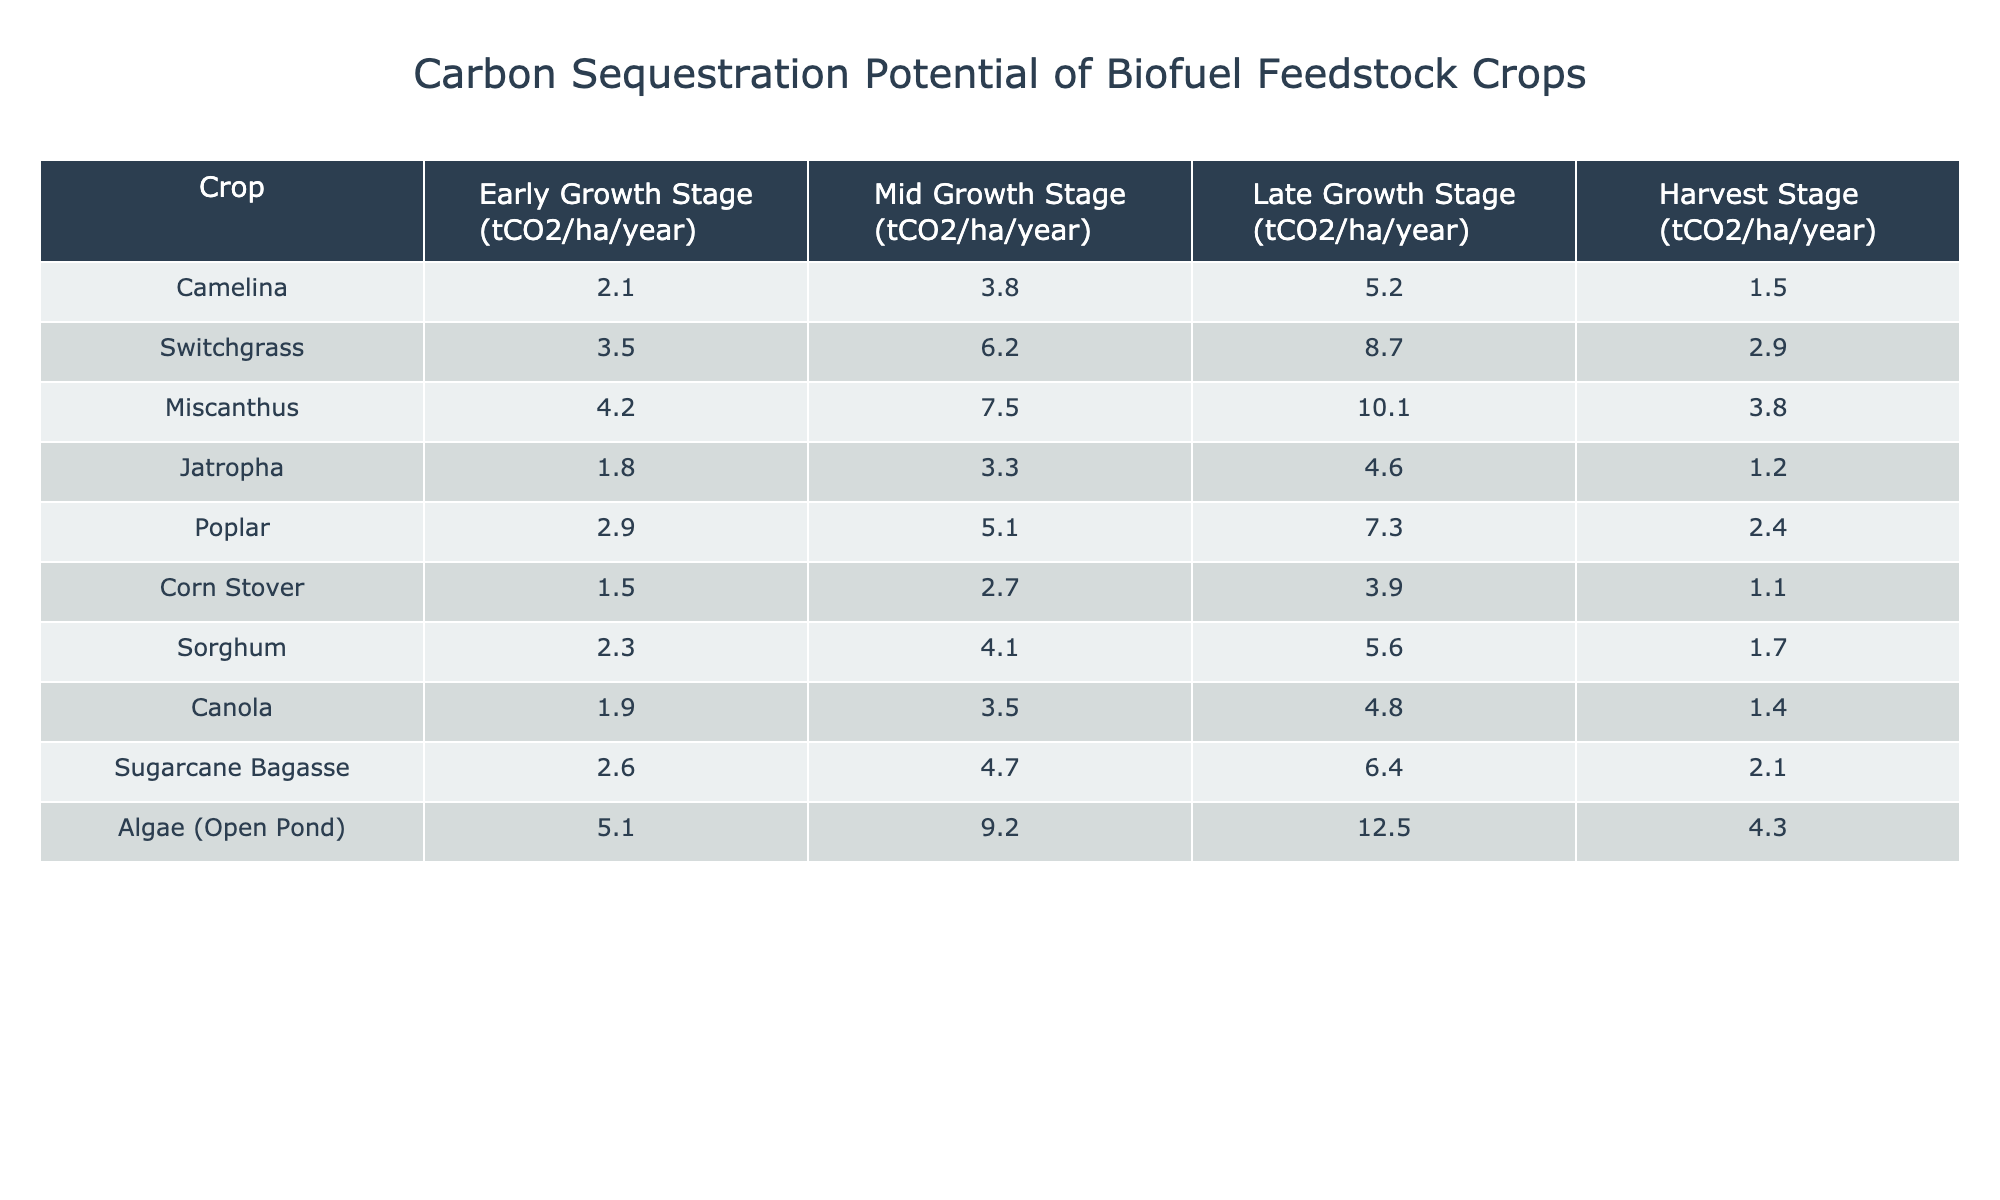What is the carbon sequestration potential of Miscanthus at the late growth stage? The table indicates that the carbon sequestration potential for Miscanthus during the late growth stage is listed as 10.1 tCO2/ha/year.
Answer: 10.1 tCO2/ha/year Which crop has the highest carbon sequestration at the mid growth stage? Referring to the table, Algae (Open Pond) has the highest value at 9.2 tCO2/ha/year during the mid growth stage.
Answer: Algae (Open Pond) What is the difference in carbon sequestration potential between the early and late growth stages of Switchgrass? For Switchgrass, the early growth stage shows 3.5 tCO2/ha/year while the late growth stage is 8.7 tCO2/ha/year. The difference is 8.7 - 3.5 = 5.2 tCO2/ha/year.
Answer: 5.2 tCO2/ha/year What is the average carbon sequestration potential at the harvest stage for all crops listed? To find the average for the harvest stage, sum the values (1.5 + 2.9 + 3.8 + 1.2 + 2.4 + 1.1 + 1.7 + 1.4 + 2.1 + 4.3 = 22.0) and divide by the number of crops (10). Hence, the average is 22.0 / 10 = 2.2 tCO2/ha/year.
Answer: 2.2 tCO2/ha/year Is the carbon sequestration potential of Jatropha higher at the mid growth stage or the harvest stage? The mid growth stage for Jatropha is 3.3 tCO2/ha/year, while the harvest stage is lower at 1.2 tCO2/ha/year, indicating that Jatropha has higher potential during the mid growth stage.
Answer: Yes Identify the crop with the lowest carbon sequestration potential at the early growth stage and state its value. The table shows Corn Stover with the lowest carbon sequestration potential at the early growth stage, which is 1.5 tCO2/ha/year.
Answer: Corn Stover, 1.5 tCO2/ha/year What is the total carbon sequestration potential of Poplar from early to late growth stages? For Poplar, the values at each growth stage are 2.9 (early) + 5.1 (mid) + 7.3 (late) = 15.3 tCO2/ha/year.
Answer: 15.3 tCO2/ha/year Is there any crop that has the same carbon sequestration potential during both the early and mid growth stages? Comparing the crops, no crop has the same values at early and mid growth stages. Therefore, the answer is no.
Answer: No Which crop sees the largest increase in carbon sequestration from the early to late growth stages? By evaluating the increases, Miscanthus changes from 4.2 (early) to 10.1 (late) for an increase of 5.9 tCO2/ha/year. Checking others confirms this is the largest increase among all crops.
Answer: Miscanthus What is the carbon sequestration potential of Algae (Open Pond) at the early growth stage compared to that of Canola? Algae (Open Pond) has a potential of 5.1 tCO2/ha/year at the early stage, whereas Canola has 1.9 tCO2/ha/year, thus Algae has a higher value.
Answer: Algae (Open Pond) has a higher potential 